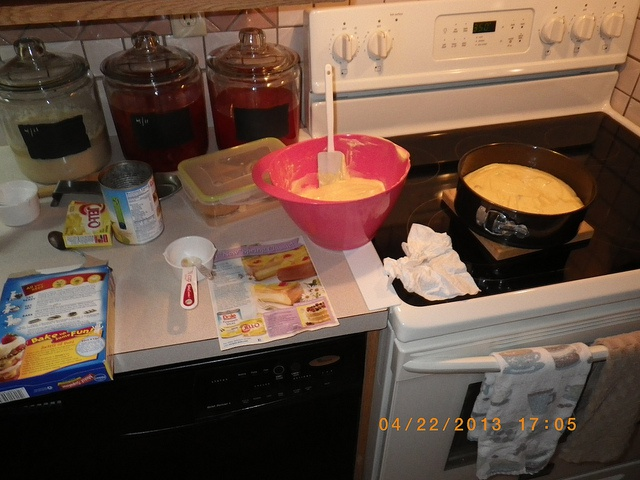Describe the objects in this image and their specific colors. I can see oven in black, gray, and tan tones, book in black, darkgray, navy, and gray tones, bowl in black, brown, salmon, and orange tones, spoon in black and tan tones, and spoon in black, gray, and darkgreen tones in this image. 